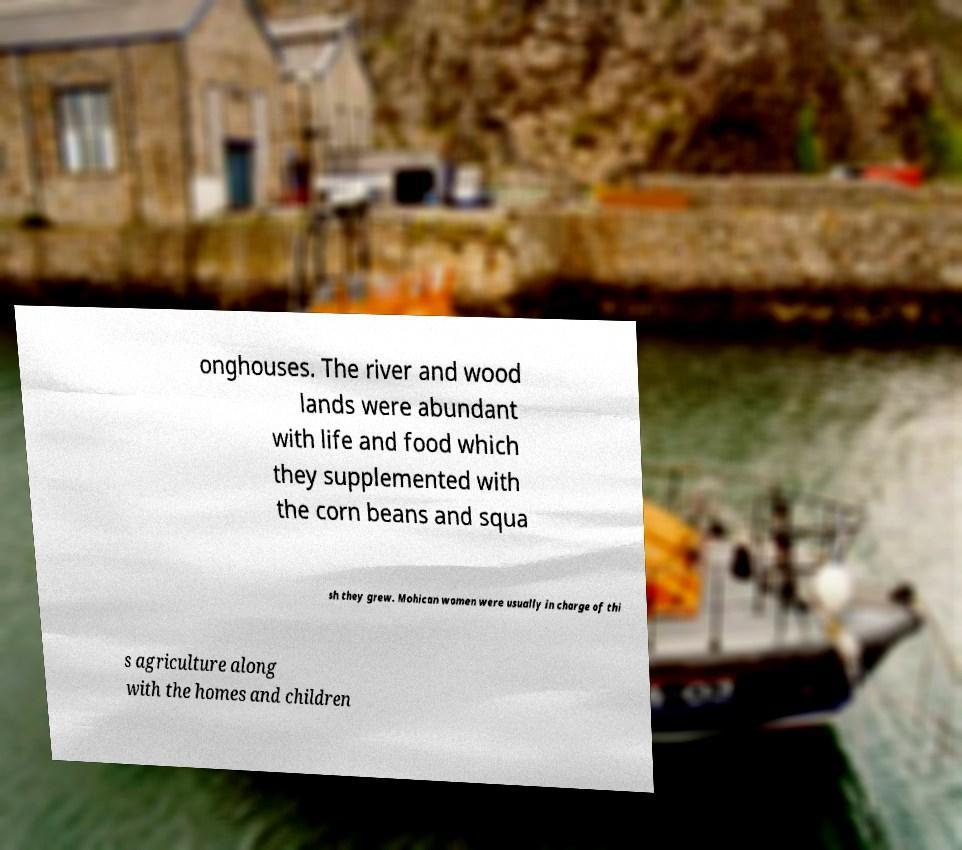Please read and relay the text visible in this image. What does it say? onghouses. The river and wood lands were abundant with life and food which they supplemented with the corn beans and squa sh they grew. Mohican women were usually in charge of thi s agriculture along with the homes and children 